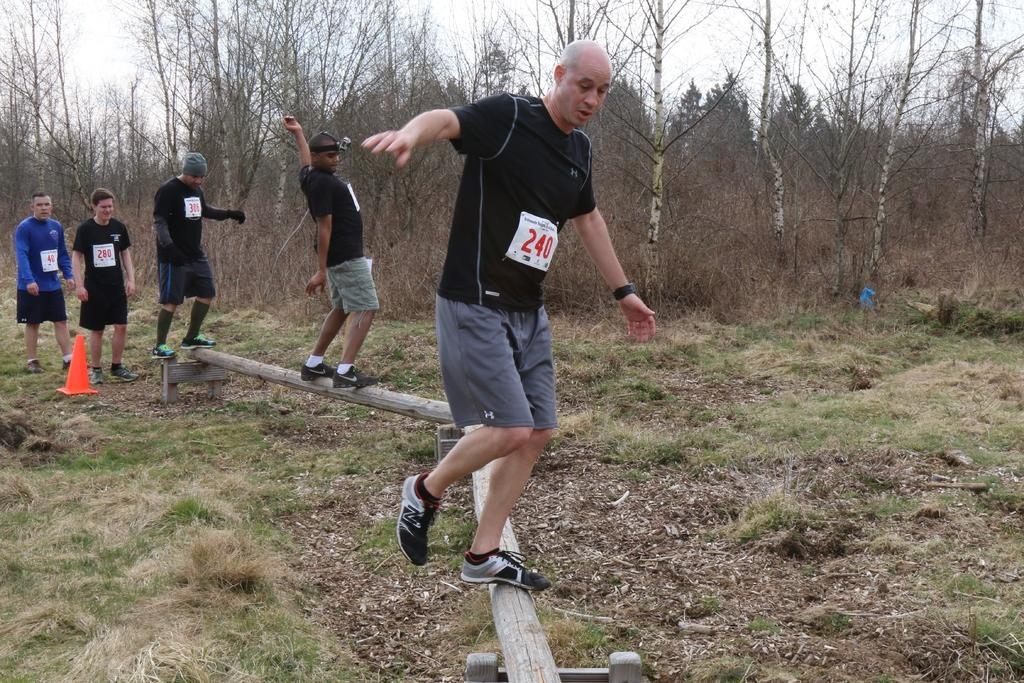What is the main setting of the image? There is a land in the image. What can be seen on the land? There is a log on the land. What are the men doing on the log? Three men are walking on the log, and two men are standing on the log. What can be seen in the background of the image? There are trees in the background of the image. What type of waste can be seen on the log in the image? There is no waste present on the log or in the image. How many men are smiling in the image? The provided facts do not mention the facial expressions of the men, so it cannot be determined if any of them are smiling. 